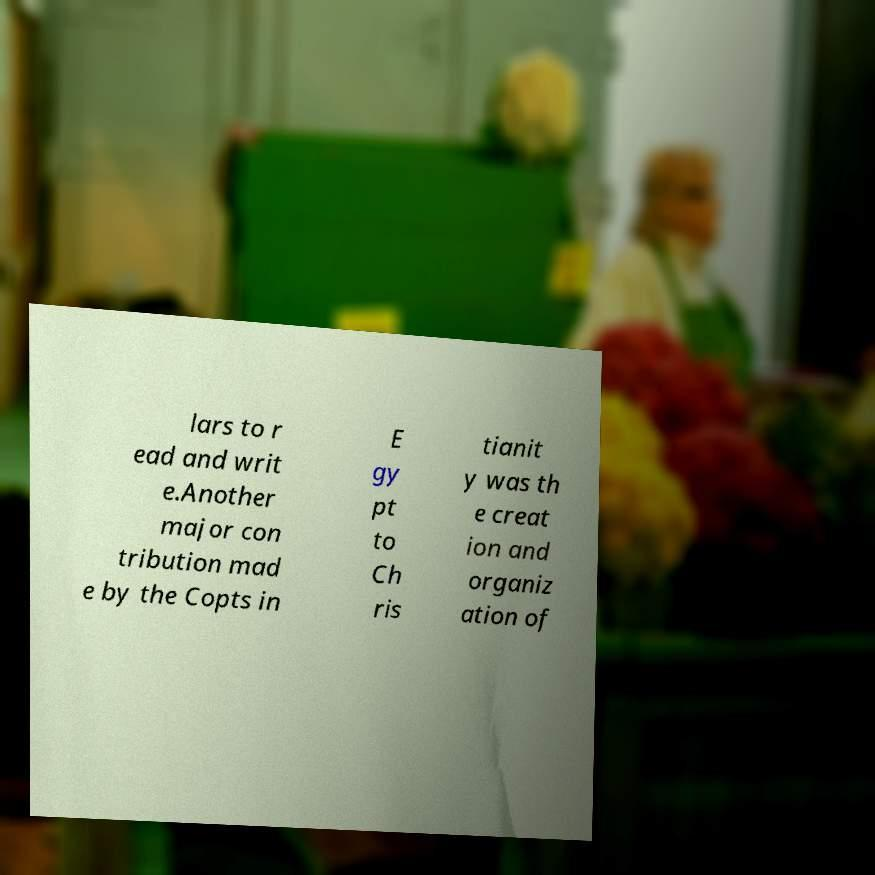For documentation purposes, I need the text within this image transcribed. Could you provide that? lars to r ead and writ e.Another major con tribution mad e by the Copts in E gy pt to Ch ris tianit y was th e creat ion and organiz ation of 